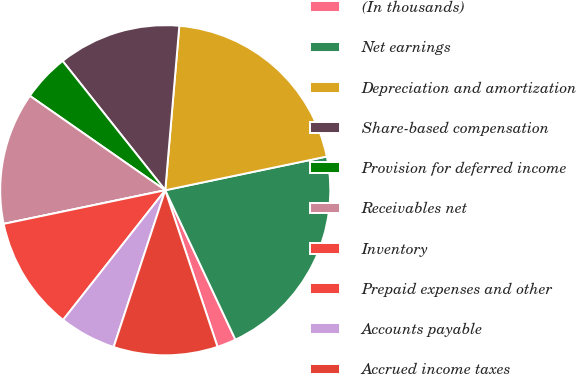Convert chart. <chart><loc_0><loc_0><loc_500><loc_500><pie_chart><fcel>(In thousands)<fcel>Net earnings<fcel>Depreciation and amortization<fcel>Share-based compensation<fcel>Provision for deferred income<fcel>Receivables net<fcel>Inventory<fcel>Prepaid expenses and other<fcel>Accounts payable<fcel>Accrued income taxes<nl><fcel>1.86%<fcel>21.29%<fcel>20.37%<fcel>12.04%<fcel>4.63%<fcel>12.96%<fcel>0.0%<fcel>11.11%<fcel>5.56%<fcel>10.19%<nl></chart> 